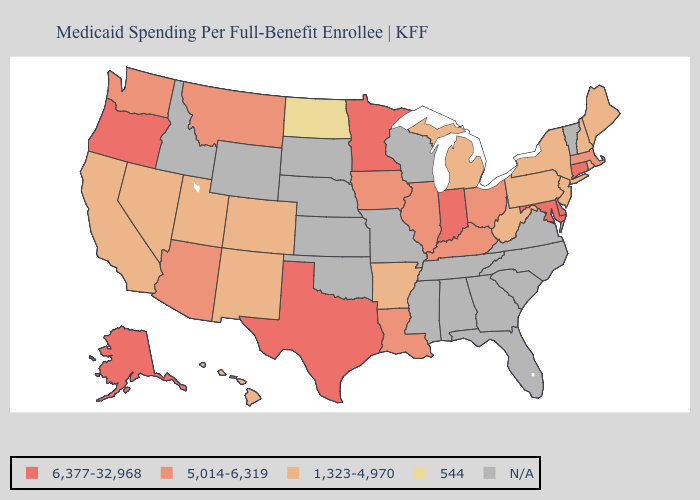Among the states that border Massachusetts , does New York have the highest value?
Write a very short answer. No. Among the states that border New York , does Pennsylvania have the lowest value?
Short answer required. Yes. How many symbols are there in the legend?
Short answer required. 5. What is the value of Texas?
Quick response, please. 6,377-32,968. Name the states that have a value in the range 5,014-6,319?
Answer briefly. Arizona, Illinois, Iowa, Kentucky, Louisiana, Massachusetts, Montana, Ohio, Washington. Is the legend a continuous bar?
Keep it brief. No. Which states hav the highest value in the West?
Write a very short answer. Alaska, Oregon. What is the value of New Mexico?
Short answer required. 1,323-4,970. Does Connecticut have the highest value in the Northeast?
Give a very brief answer. Yes. What is the highest value in the Northeast ?
Give a very brief answer. 6,377-32,968. Does Connecticut have the highest value in the USA?
Give a very brief answer. Yes. What is the lowest value in the South?
Be succinct. 1,323-4,970. 